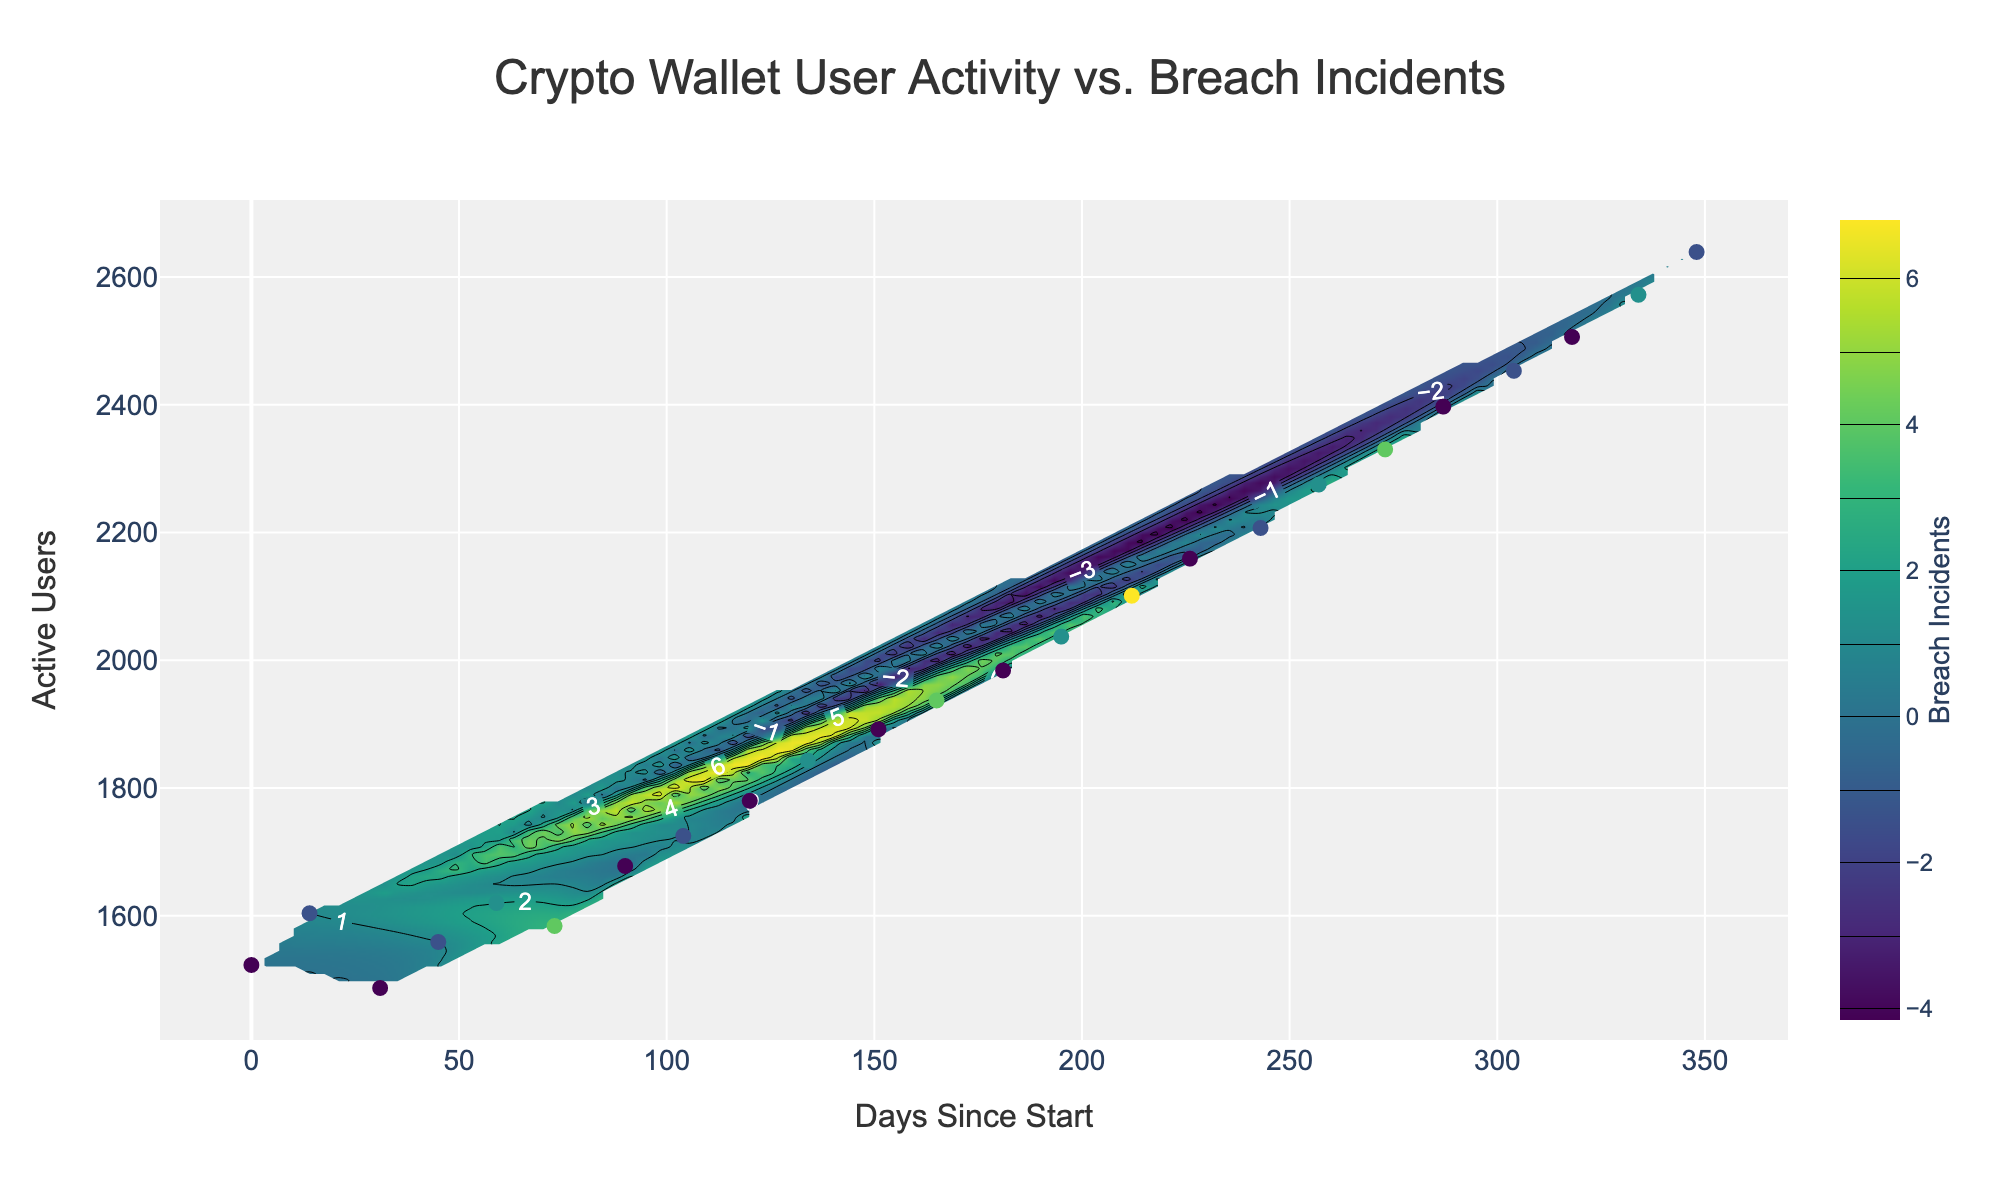What does the title of the plot say? The title is located at the top of the plot and represents the main subject of the figure. It helps in understanding what the plot is about. In this case, the title indicates the contents of the plot.
Answer: Crypto Wallet User Activity vs. Breach Incidents What are the labels on the x-axis and y-axis? The labels on the axes provide the scale and the meaning of the data points. The x-axis typically denotes time or sequence, while the y-axis often represents the value being measured. Here, the x-axis measures "Days Since Start" and the y-axis measures "Active Users."
Answer: Days Since Start, Active Users How many data points are shown on the scatter plot? The scatter plot shows individual data points for active users and breach incidents at specific times. You can count the markers to determine the number of data points.
Answer: 24 What does the color of the contour plot represent? The color of the contour plot represents the density of breach incidents. The color bar on the right side of the plot shows how different colors correspond to the number of breach incidents.
Answer: Breach Incidents When was the highest density of breach incidents observed, relative to the plot? To determine this, look for the darkest regions in the contour plot which indicate the highest density of breach incidents. Cross-reference these regions with the corresponding x-axis (time) and y-axis (active users) values. This can be seen in the middle of the plot where the colors are darkest.
Answer: Around mid-2022 What trend do you notice in the relationship between active users and breach incidents? By examining the contour lines and scatter points, you can observe how active users and breach incidents are related. Look for patterns, such as whether higher numbers of active users correlate with more breach incidents. As active users increase over time, breach incidents also appear to generally increase, indicating a potential correlation.
Answer: More active users, more breach incidents How does the breach incident density change over time? Analyze the color gradients along the x-axis (Days Since Start) to observe patterns of breach incidents over time. The colors become darker as we move from the start to the end, indicating more breach incidents as time progresses.
Answer: Increases over time Compare the number of active users at the beginning and the end of the period. What do you observe? To compare, check the y-axis values of the scatter points at the beginning (lowest x-values) and the end (highest x-values) of the plot. The active users increase from around 1500 at the beginning to over 2600 at the end.
Answer: Active users increased from around 1500 to over 2600 What can you infer about the breach incident density when the number of active users is around 2000? Focus on the color around the y-value of 2000 on the plot to infer breach incident density. The plot suggests significant breach incidents when active users are around 2000, indicated by darker colors.
Answer: High density 